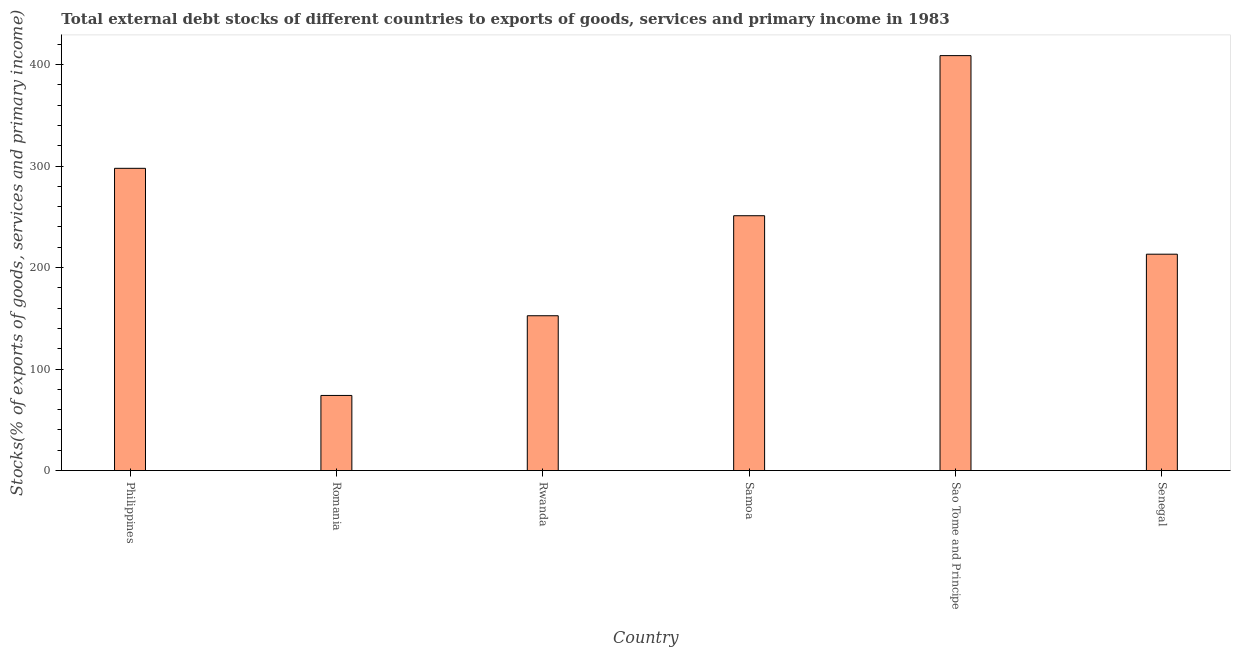Does the graph contain any zero values?
Your response must be concise. No. Does the graph contain grids?
Provide a succinct answer. No. What is the title of the graph?
Provide a succinct answer. Total external debt stocks of different countries to exports of goods, services and primary income in 1983. What is the label or title of the X-axis?
Offer a terse response. Country. What is the label or title of the Y-axis?
Offer a terse response. Stocks(% of exports of goods, services and primary income). What is the external debt stocks in Sao Tome and Principe?
Give a very brief answer. 408.73. Across all countries, what is the maximum external debt stocks?
Give a very brief answer. 408.73. Across all countries, what is the minimum external debt stocks?
Provide a succinct answer. 74. In which country was the external debt stocks maximum?
Give a very brief answer. Sao Tome and Principe. In which country was the external debt stocks minimum?
Offer a very short reply. Romania. What is the sum of the external debt stocks?
Provide a short and direct response. 1397.14. What is the difference between the external debt stocks in Romania and Sao Tome and Principe?
Provide a succinct answer. -334.73. What is the average external debt stocks per country?
Offer a terse response. 232.86. What is the median external debt stocks?
Offer a very short reply. 232.09. In how many countries, is the external debt stocks greater than 220 %?
Offer a very short reply. 3. What is the ratio of the external debt stocks in Romania to that in Senegal?
Give a very brief answer. 0.35. Is the difference between the external debt stocks in Philippines and Samoa greater than the difference between any two countries?
Your answer should be very brief. No. What is the difference between the highest and the second highest external debt stocks?
Make the answer very short. 111. What is the difference between the highest and the lowest external debt stocks?
Your response must be concise. 334.73. How many countries are there in the graph?
Offer a terse response. 6. Are the values on the major ticks of Y-axis written in scientific E-notation?
Your response must be concise. No. What is the Stocks(% of exports of goods, services and primary income) of Philippines?
Provide a short and direct response. 297.73. What is the Stocks(% of exports of goods, services and primary income) of Romania?
Your answer should be compact. 74. What is the Stocks(% of exports of goods, services and primary income) of Rwanda?
Offer a very short reply. 152.52. What is the Stocks(% of exports of goods, services and primary income) in Samoa?
Provide a succinct answer. 251.03. What is the Stocks(% of exports of goods, services and primary income) in Sao Tome and Principe?
Provide a succinct answer. 408.73. What is the Stocks(% of exports of goods, services and primary income) in Senegal?
Keep it short and to the point. 213.14. What is the difference between the Stocks(% of exports of goods, services and primary income) in Philippines and Romania?
Ensure brevity in your answer.  223.73. What is the difference between the Stocks(% of exports of goods, services and primary income) in Philippines and Rwanda?
Offer a very short reply. 145.21. What is the difference between the Stocks(% of exports of goods, services and primary income) in Philippines and Samoa?
Your answer should be compact. 46.69. What is the difference between the Stocks(% of exports of goods, services and primary income) in Philippines and Sao Tome and Principe?
Offer a very short reply. -111. What is the difference between the Stocks(% of exports of goods, services and primary income) in Philippines and Senegal?
Your answer should be very brief. 84.59. What is the difference between the Stocks(% of exports of goods, services and primary income) in Romania and Rwanda?
Give a very brief answer. -78.52. What is the difference between the Stocks(% of exports of goods, services and primary income) in Romania and Samoa?
Offer a very short reply. -177.03. What is the difference between the Stocks(% of exports of goods, services and primary income) in Romania and Sao Tome and Principe?
Ensure brevity in your answer.  -334.73. What is the difference between the Stocks(% of exports of goods, services and primary income) in Romania and Senegal?
Provide a succinct answer. -139.14. What is the difference between the Stocks(% of exports of goods, services and primary income) in Rwanda and Samoa?
Give a very brief answer. -98.52. What is the difference between the Stocks(% of exports of goods, services and primary income) in Rwanda and Sao Tome and Principe?
Make the answer very short. -256.21. What is the difference between the Stocks(% of exports of goods, services and primary income) in Rwanda and Senegal?
Your answer should be compact. -60.62. What is the difference between the Stocks(% of exports of goods, services and primary income) in Samoa and Sao Tome and Principe?
Your answer should be compact. -157.7. What is the difference between the Stocks(% of exports of goods, services and primary income) in Samoa and Senegal?
Provide a short and direct response. 37.89. What is the difference between the Stocks(% of exports of goods, services and primary income) in Sao Tome and Principe and Senegal?
Your response must be concise. 195.59. What is the ratio of the Stocks(% of exports of goods, services and primary income) in Philippines to that in Romania?
Your response must be concise. 4.02. What is the ratio of the Stocks(% of exports of goods, services and primary income) in Philippines to that in Rwanda?
Your response must be concise. 1.95. What is the ratio of the Stocks(% of exports of goods, services and primary income) in Philippines to that in Samoa?
Ensure brevity in your answer.  1.19. What is the ratio of the Stocks(% of exports of goods, services and primary income) in Philippines to that in Sao Tome and Principe?
Provide a succinct answer. 0.73. What is the ratio of the Stocks(% of exports of goods, services and primary income) in Philippines to that in Senegal?
Keep it short and to the point. 1.4. What is the ratio of the Stocks(% of exports of goods, services and primary income) in Romania to that in Rwanda?
Ensure brevity in your answer.  0.48. What is the ratio of the Stocks(% of exports of goods, services and primary income) in Romania to that in Samoa?
Your response must be concise. 0.29. What is the ratio of the Stocks(% of exports of goods, services and primary income) in Romania to that in Sao Tome and Principe?
Give a very brief answer. 0.18. What is the ratio of the Stocks(% of exports of goods, services and primary income) in Romania to that in Senegal?
Provide a succinct answer. 0.35. What is the ratio of the Stocks(% of exports of goods, services and primary income) in Rwanda to that in Samoa?
Ensure brevity in your answer.  0.61. What is the ratio of the Stocks(% of exports of goods, services and primary income) in Rwanda to that in Sao Tome and Principe?
Give a very brief answer. 0.37. What is the ratio of the Stocks(% of exports of goods, services and primary income) in Rwanda to that in Senegal?
Your response must be concise. 0.72. What is the ratio of the Stocks(% of exports of goods, services and primary income) in Samoa to that in Sao Tome and Principe?
Provide a short and direct response. 0.61. What is the ratio of the Stocks(% of exports of goods, services and primary income) in Samoa to that in Senegal?
Your answer should be compact. 1.18. What is the ratio of the Stocks(% of exports of goods, services and primary income) in Sao Tome and Principe to that in Senegal?
Provide a succinct answer. 1.92. 